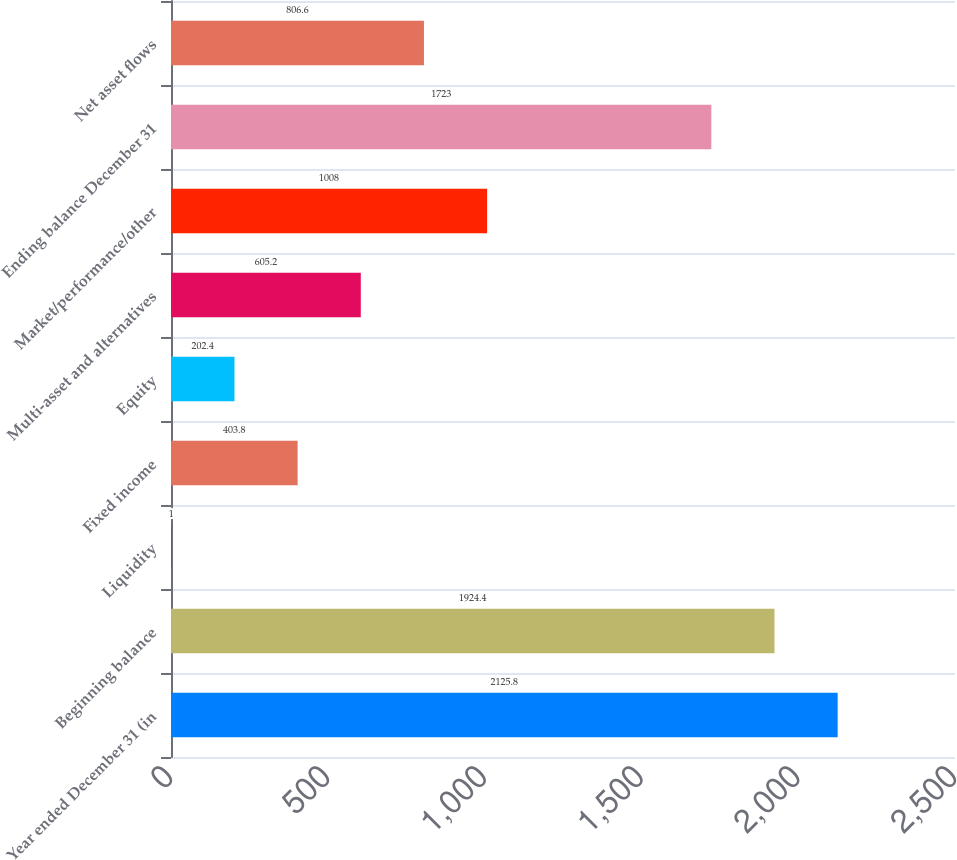<chart> <loc_0><loc_0><loc_500><loc_500><bar_chart><fcel>Year ended December 31 (in<fcel>Beginning balance<fcel>Liquidity<fcel>Fixed income<fcel>Equity<fcel>Multi-asset and alternatives<fcel>Market/performance/other<fcel>Ending balance December 31<fcel>Net asset flows<nl><fcel>2125.8<fcel>1924.4<fcel>1<fcel>403.8<fcel>202.4<fcel>605.2<fcel>1008<fcel>1723<fcel>806.6<nl></chart> 